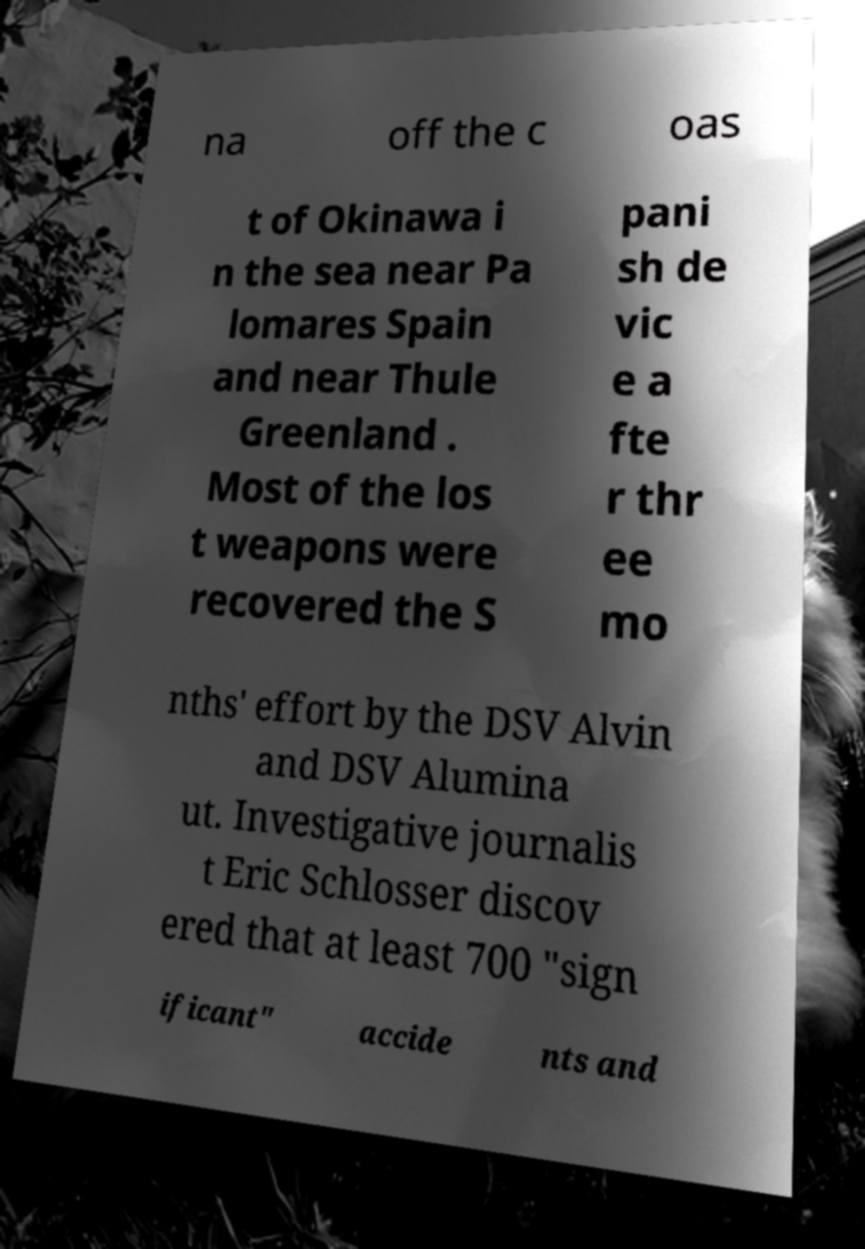Please read and relay the text visible in this image. What does it say? na off the c oas t of Okinawa i n the sea near Pa lomares Spain and near Thule Greenland . Most of the los t weapons were recovered the S pani sh de vic e a fte r thr ee mo nths' effort by the DSV Alvin and DSV Alumina ut. Investigative journalis t Eric Schlosser discov ered that at least 700 "sign ificant" accide nts and 